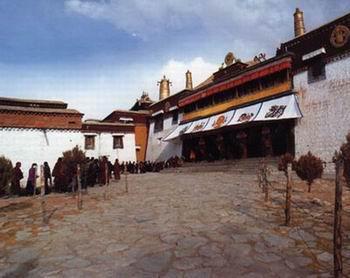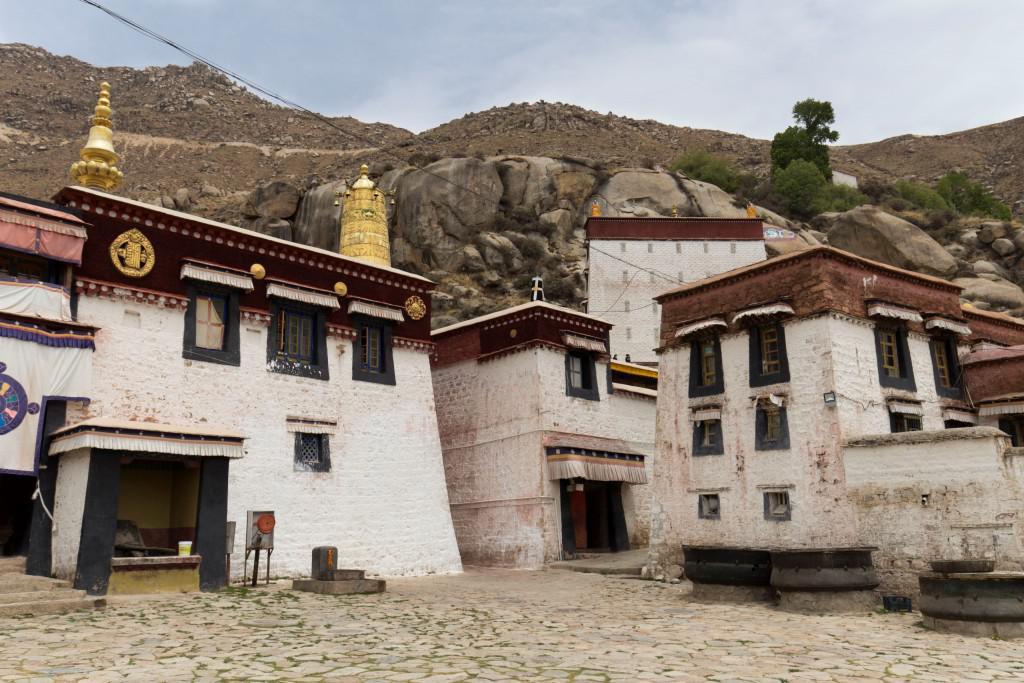The first image is the image on the left, the second image is the image on the right. Analyze the images presented: Is the assertion "People walk the streets in an historic area." valid? Answer yes or no. No. The first image is the image on the left, the second image is the image on the right. Analyze the images presented: Is the assertion "Multiple domes topped with crosses are included in one image." valid? Answer yes or no. No. 